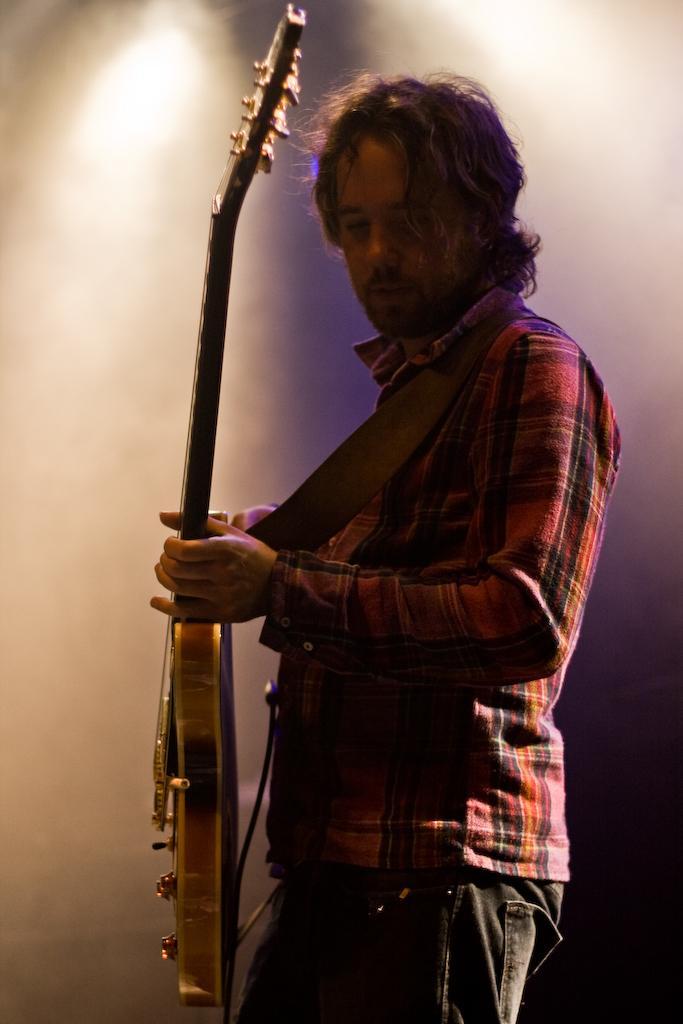Describe this image in one or two sentences. In this picture we can see a man standing and holding a guitar in his hands. Background is blurry. 